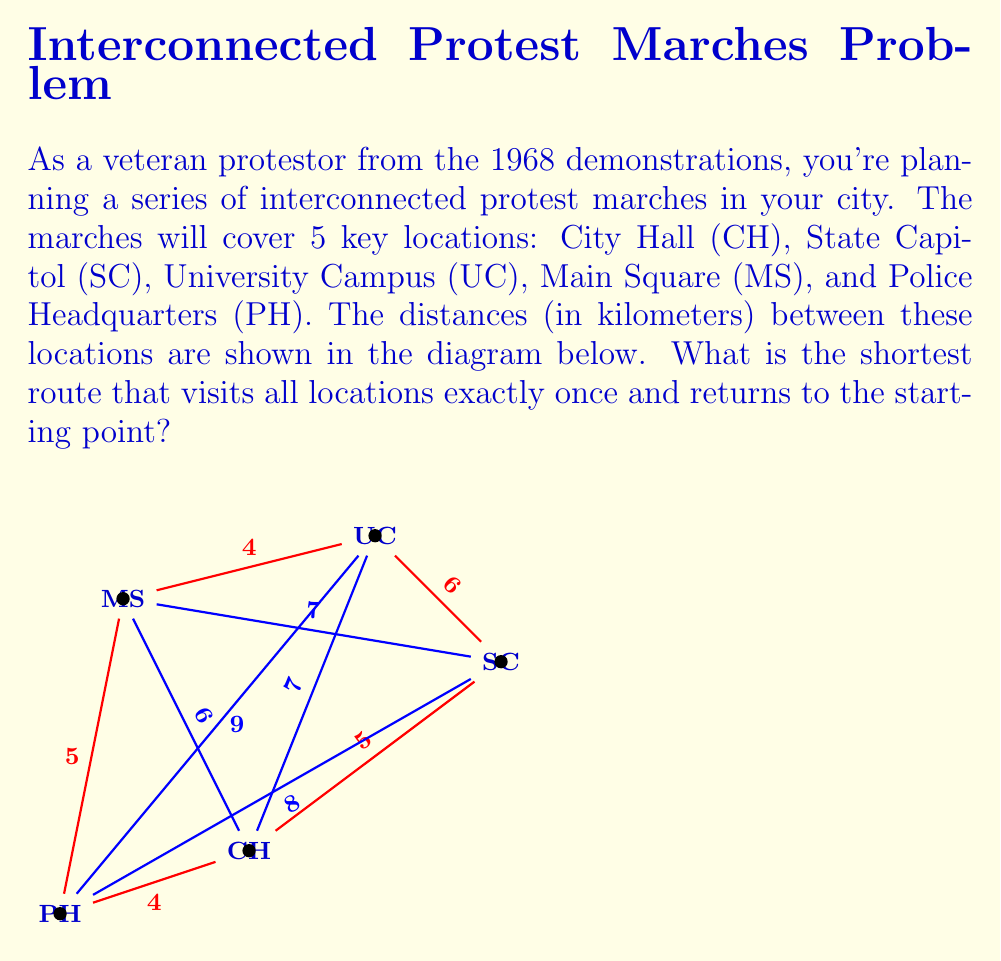Solve this math problem. To solve this problem, we need to find the shortest Hamiltonian cycle in the given graph. This is known as the Traveling Salesman Problem (TSP), which is NP-hard. For a small graph like this, we can use a brute-force approach to find the optimal solution.

Steps:
1) List all possible permutations of the 5 locations (excluding the start/end point).
2) For each permutation, calculate the total distance of the route.
3) Choose the permutation with the shortest total distance.

There are 4! = 24 possible permutations. Let's calculate a few to illustrate:

1) CH - SC - UC - MS - PH - CH
   Distance = 5 + 6 + 4 + 5 + 4 = 24 km

2) CH - SC - UC - PH - MS - CH
   Distance = 5 + 6 + 9 + 5 + 6 = 31 km

3) CH - UC - MS - PH - SC - CH
   Distance = 7 + 4 + 5 + 8 + 5 = 29 km

After calculating all 24 permutations, we find that the shortest route is:

CH - SC - UC - MS - PH - CH

The total distance of this route is:
$$5 + 6 + 4 + 5 + 4 = 24 \text{ km}$$

This route minimizes the total distance while visiting each location once and returning to the starting point.
Answer: CH - SC - UC - MS - PH - CH, 24 km 